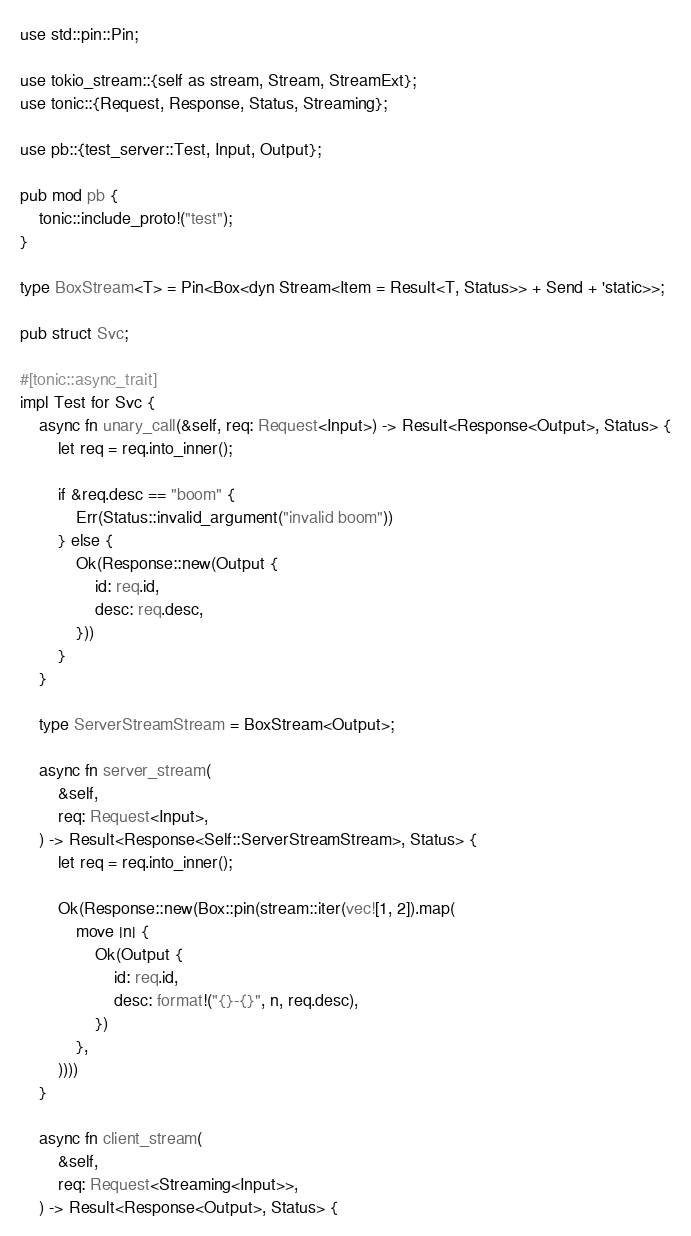<code> <loc_0><loc_0><loc_500><loc_500><_Rust_>use std::pin::Pin;

use tokio_stream::{self as stream, Stream, StreamExt};
use tonic::{Request, Response, Status, Streaming};

use pb::{test_server::Test, Input, Output};

pub mod pb {
    tonic::include_proto!("test");
}

type BoxStream<T> = Pin<Box<dyn Stream<Item = Result<T, Status>> + Send + 'static>>;

pub struct Svc;

#[tonic::async_trait]
impl Test for Svc {
    async fn unary_call(&self, req: Request<Input>) -> Result<Response<Output>, Status> {
        let req = req.into_inner();

        if &req.desc == "boom" {
            Err(Status::invalid_argument("invalid boom"))
        } else {
            Ok(Response::new(Output {
                id: req.id,
                desc: req.desc,
            }))
        }
    }

    type ServerStreamStream = BoxStream<Output>;

    async fn server_stream(
        &self,
        req: Request<Input>,
    ) -> Result<Response<Self::ServerStreamStream>, Status> {
        let req = req.into_inner();

        Ok(Response::new(Box::pin(stream::iter(vec![1, 2]).map(
            move |n| {
                Ok(Output {
                    id: req.id,
                    desc: format!("{}-{}", n, req.desc),
                })
            },
        ))))
    }

    async fn client_stream(
        &self,
        req: Request<Streaming<Input>>,
    ) -> Result<Response<Output>, Status> {</code> 